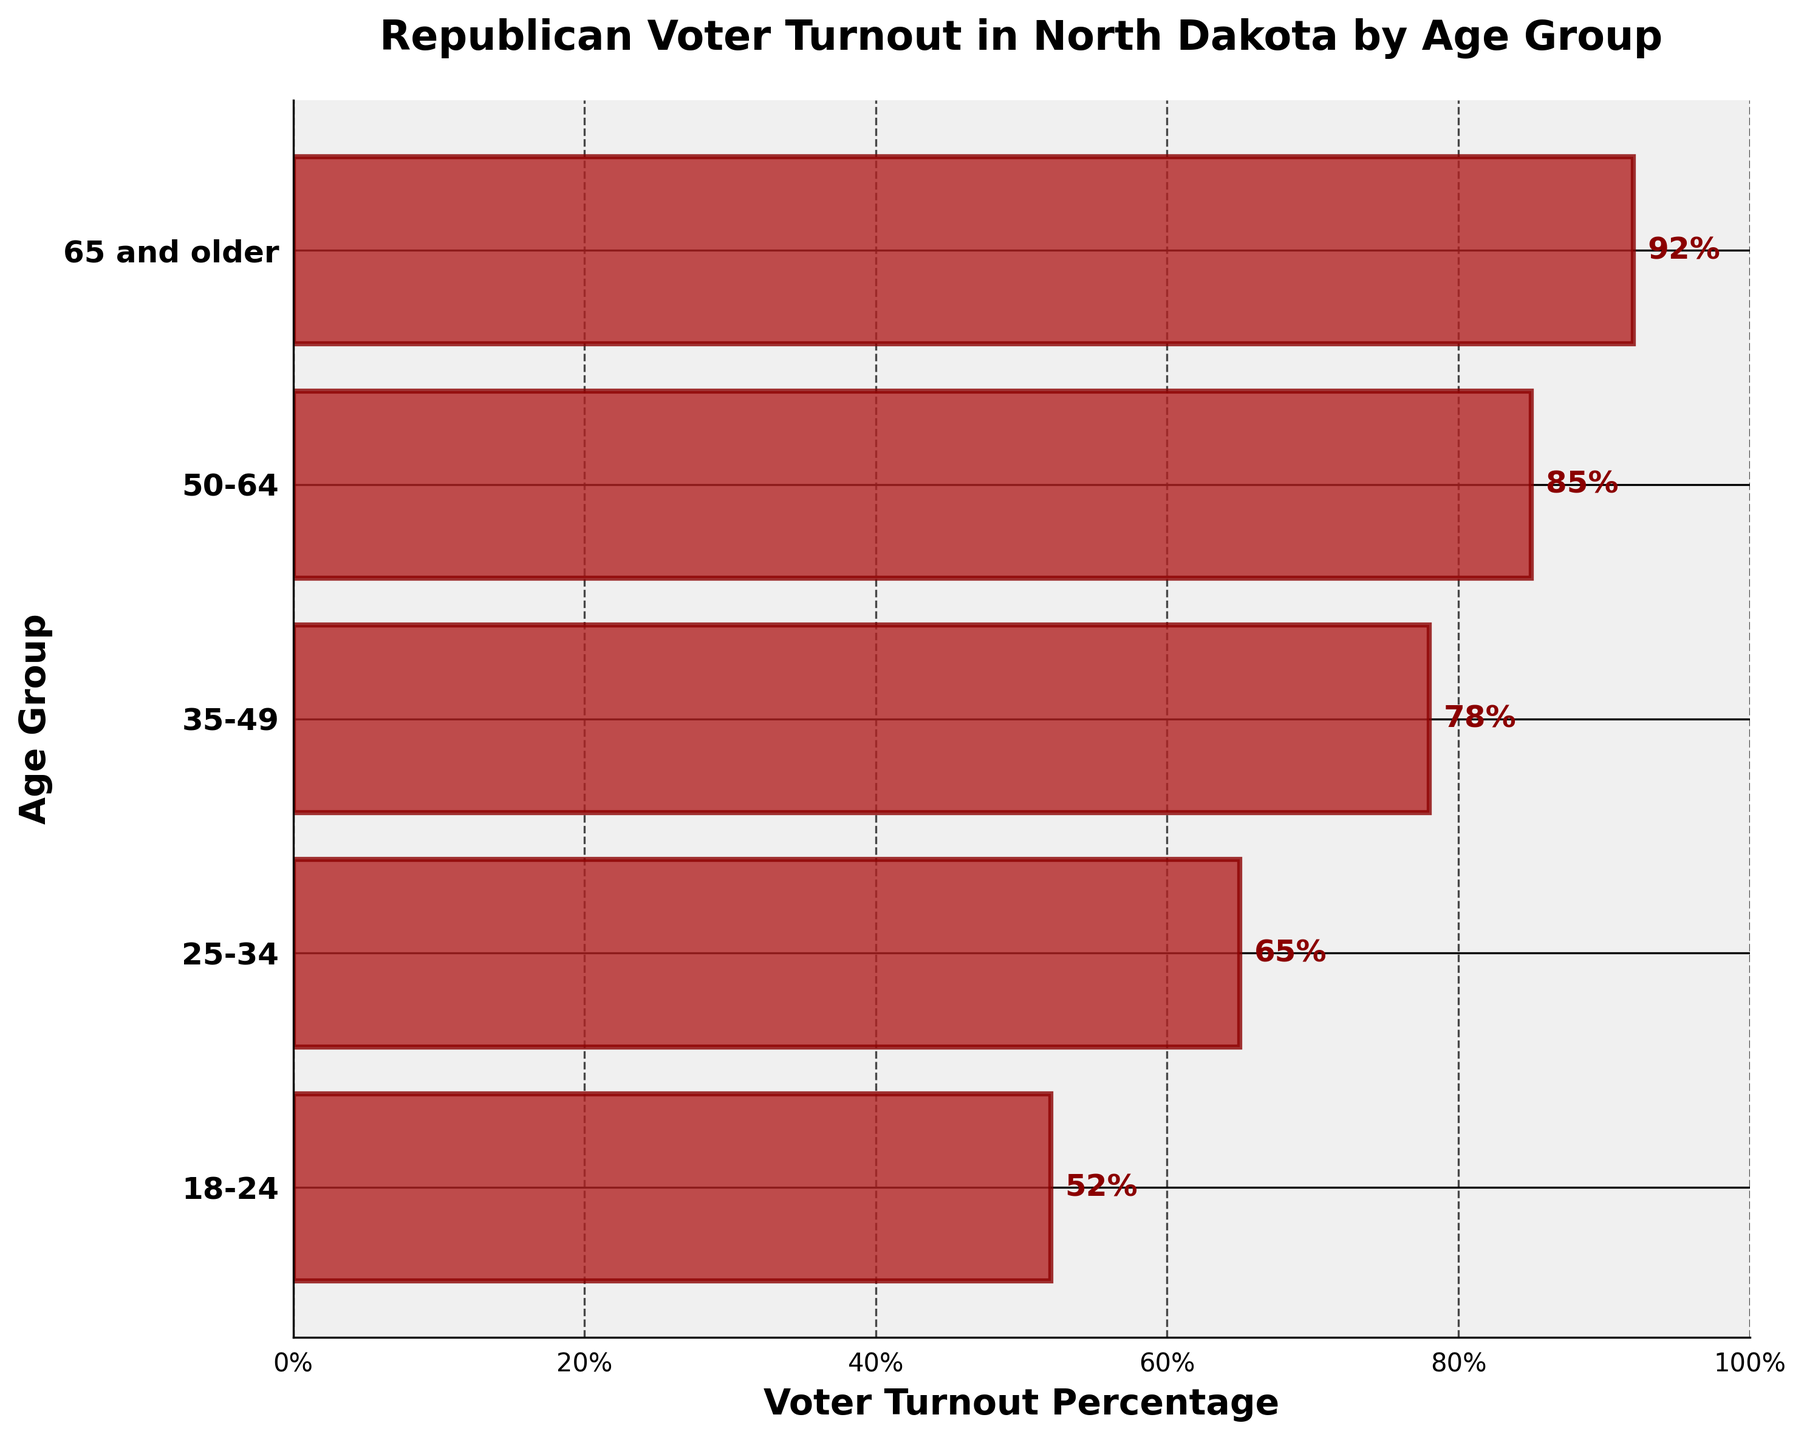How many age groups are represented in the chart? Count the number of age groups listed on the y-axis. There are 5 age groups labeled.
Answer: 5 What is the title of the chart? The title is located at the top of the chart, reading "Republican Voter Turnout in North Dakota by Age Group."
Answer: Republican Voter Turnout in North Dakota by Age Group Which age group has the highest voter turnout percentage? Identify the bar with the greatest length on the x-axis. The "65 and older" group has the highest value at 92%.
Answer: 65 and older Which age group has the lowest voter turnout percentage? Identify the bar with the smallest length on the x-axis. The "18-24" group shows the lowest value at 52%.
Answer: 18-24 What's the average voter turnout percentage across all age groups? Sum the percentages (52 + 65 + 78 + 85 + 92) and divide by the number of age groups (5). The total is 372, and the average is 372 ÷ 5 = 74.4%.
Answer: 74.4 What is the difference in voter turnout between the "35-49" and "18-24" age groups? Subtract the voter turnout percentage of "18-24" from "35-49" (78 - 52). The difference is 26%.
Answer: 26 Between the "50-64" and "25-34" age groups, which has a greater voter turnout percentage and by how much? Compare the two percentages: 85% for the "50-64" group and 65% for the "25-34" group. The "50-64" group has 20% greater voter turnout (85 - 65).
Answer: 50-64, by 20% Is there a consistent trend between age and voter turnout percentage? Analyze the bar lengths: the chart shows that voter turnout generally increases with age.
Answer: Yes Which age groups have voter turnout percentages greater than or equal to the average voter turnout percentage? The average is 74.4%. The age groups "35-49," "50-64," and "65 and older" all have turnout greater than 74.4%.
Answer: 35-49, 50-64, 65 and older 